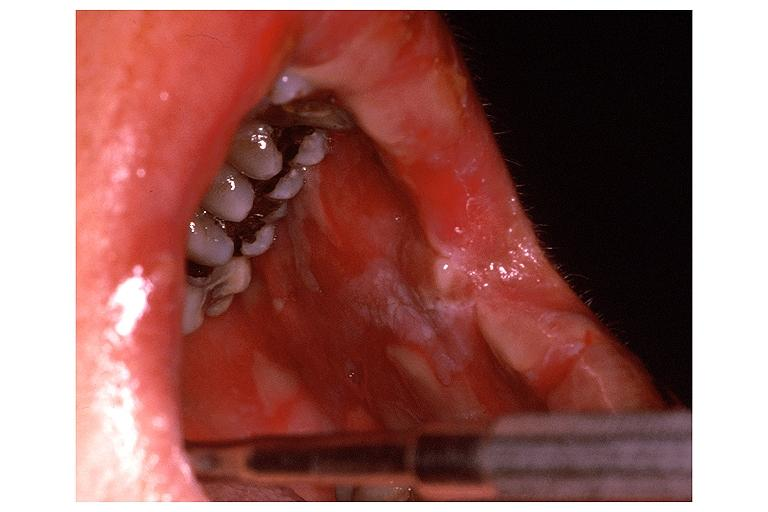s oral present?
Answer the question using a single word or phrase. Yes 